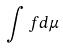Convert formula to latex. <formula><loc_0><loc_0><loc_500><loc_500>\int f d \mu</formula> 